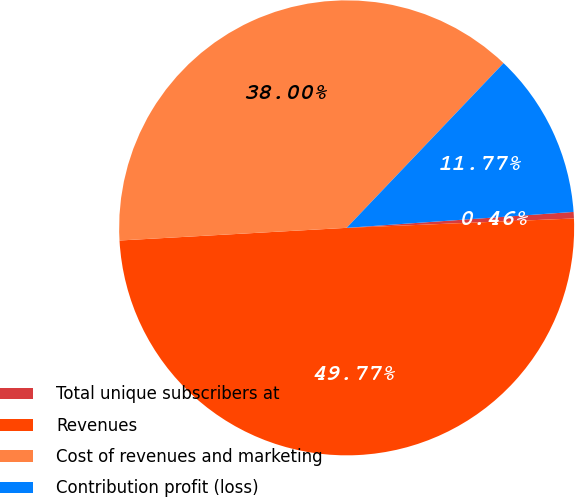<chart> <loc_0><loc_0><loc_500><loc_500><pie_chart><fcel>Total unique subscribers at<fcel>Revenues<fcel>Cost of revenues and marketing<fcel>Contribution profit (loss)<nl><fcel>0.46%<fcel>49.77%<fcel>38.0%<fcel>11.77%<nl></chart> 